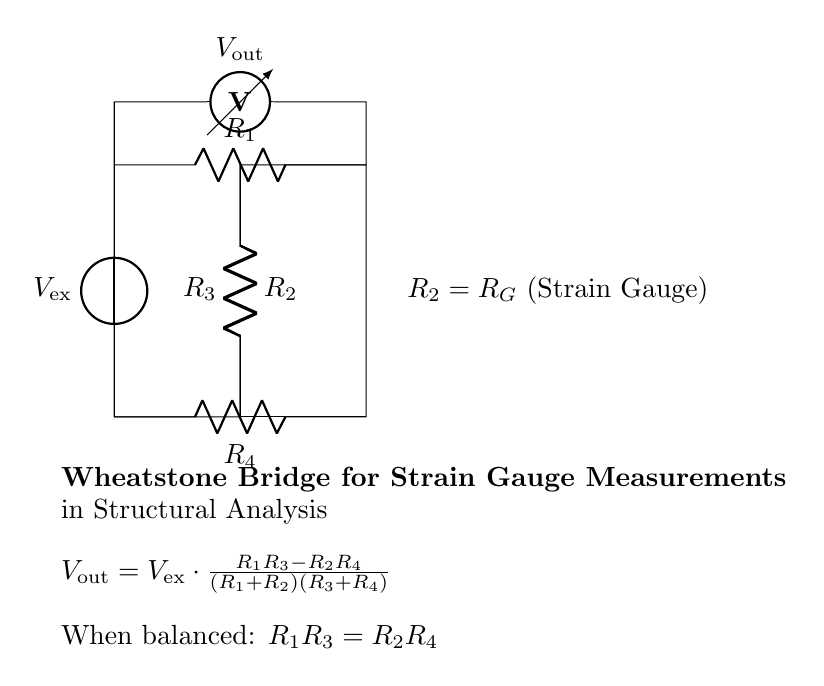What is the reference voltage source in the circuit? The circuit has a voltage source specified as V_ex, which serves as the input reference voltage for the Wheatstone bridge.
Answer: V_ex What type of components are R_1, R_2, R_3, and R_4? These components represent resistors, which are essential in forming the Wheatstone bridge configuration for measuring resistance changes due to strain.
Answer: Resistors What does V_out represent in the circuit? V_out is the output voltage of the Wheatstone bridge, which indicates the difference in potential caused by any strain affecting the strain gauge (R_2).
Answer: Output voltage What happens to the Wheatstone bridge when balanced? When balanced, the equation R_1R_3 equals R_2R_4, meaning there is no voltage difference across V_out indicating that the resistors are proportionally set.
Answer: R_1R_3 = R_2R_4 What is the role of the strain gauge in this circuit? The strain gauge, represented by R_2, changes its resistance when subjected to mechanical stress, affecting the output voltage V_out.
Answer: Measure strain How is V_out calculated in this circuit? V_out is calculated using the formula provided, which involves the resistances R_1, R_2, R_3, and R_4, as well as the input voltage V_ex. It reflects the proportional changes due to strain.
Answer: V_out = V_ex * (R_1R_3 - R_2R_4) / ((R_1 + R_2)(R_3 + R_4)) What does the voltmeter measure in this Wheatstone bridge? The voltmeter measures the output voltage V_out between the midpoints of the resistors connected in the bridge, indicating any imbalance due to resistance changes.
Answer: Measure output voltage 